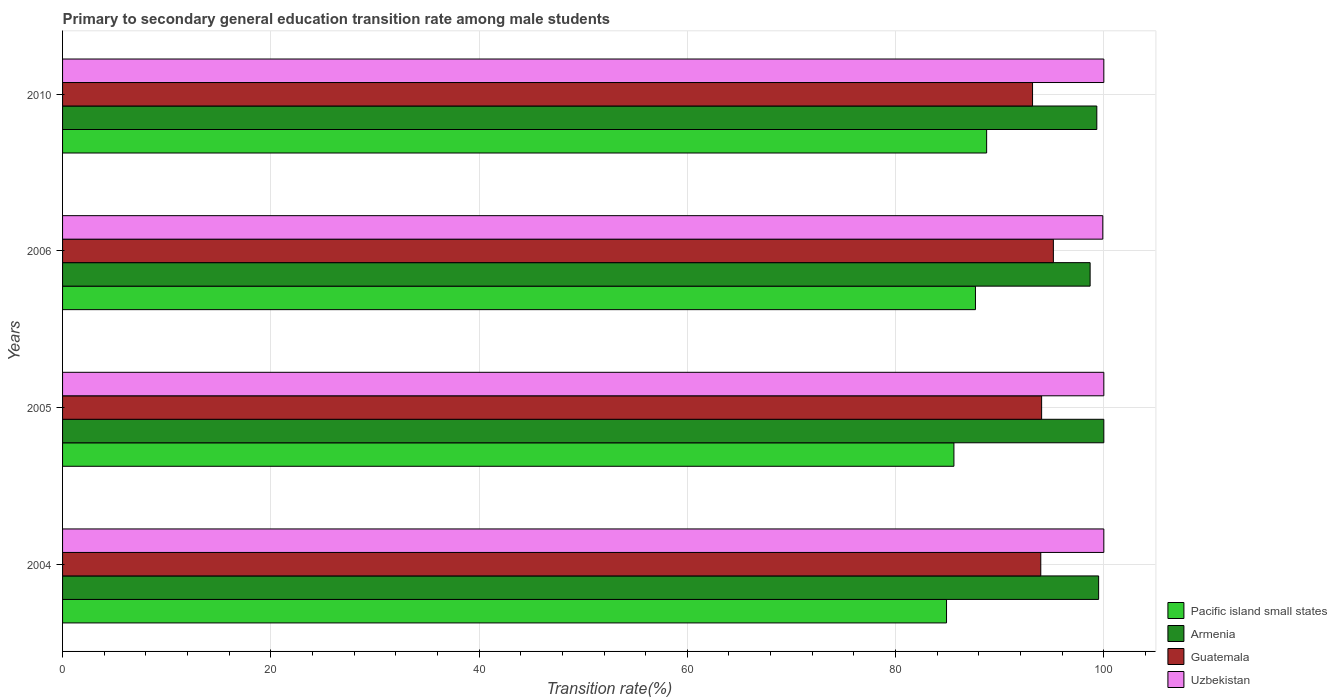How many different coloured bars are there?
Your answer should be very brief. 4. How many groups of bars are there?
Provide a succinct answer. 4. Are the number of bars on each tick of the Y-axis equal?
Provide a short and direct response. Yes. How many bars are there on the 4th tick from the top?
Ensure brevity in your answer.  4. How many bars are there on the 1st tick from the bottom?
Give a very brief answer. 4. What is the label of the 1st group of bars from the top?
Offer a very short reply. 2010. In how many cases, is the number of bars for a given year not equal to the number of legend labels?
Provide a short and direct response. 0. Across all years, what is the maximum transition rate in Uzbekistan?
Give a very brief answer. 100. Across all years, what is the minimum transition rate in Pacific island small states?
Keep it short and to the point. 84.89. In which year was the transition rate in Uzbekistan maximum?
Keep it short and to the point. 2004. What is the total transition rate in Uzbekistan in the graph?
Provide a short and direct response. 399.9. What is the difference between the transition rate in Armenia in 2006 and that in 2010?
Keep it short and to the point. -0.64. What is the difference between the transition rate in Armenia in 2010 and the transition rate in Pacific island small states in 2005?
Your response must be concise. 13.72. What is the average transition rate in Guatemala per year?
Make the answer very short. 94.07. In the year 2010, what is the difference between the transition rate in Armenia and transition rate in Pacific island small states?
Make the answer very short. 10.58. In how many years, is the transition rate in Guatemala greater than 12 %?
Your answer should be very brief. 4. What is the ratio of the transition rate in Armenia in 2005 to that in 2010?
Keep it short and to the point. 1.01. What is the difference between the highest and the lowest transition rate in Armenia?
Your response must be concise. 1.32. Is it the case that in every year, the sum of the transition rate in Pacific island small states and transition rate in Uzbekistan is greater than the sum of transition rate in Armenia and transition rate in Guatemala?
Your answer should be compact. Yes. What does the 2nd bar from the top in 2004 represents?
Make the answer very short. Guatemala. What does the 1st bar from the bottom in 2006 represents?
Your answer should be compact. Pacific island small states. Are all the bars in the graph horizontal?
Your answer should be very brief. Yes. How many years are there in the graph?
Make the answer very short. 4. Are the values on the major ticks of X-axis written in scientific E-notation?
Offer a terse response. No. Does the graph contain grids?
Make the answer very short. Yes. Where does the legend appear in the graph?
Provide a short and direct response. Bottom right. How many legend labels are there?
Make the answer very short. 4. What is the title of the graph?
Offer a very short reply. Primary to secondary general education transition rate among male students. What is the label or title of the X-axis?
Your answer should be very brief. Transition rate(%). What is the Transition rate(%) of Pacific island small states in 2004?
Your response must be concise. 84.89. What is the Transition rate(%) of Armenia in 2004?
Offer a very short reply. 99.5. What is the Transition rate(%) of Guatemala in 2004?
Give a very brief answer. 93.94. What is the Transition rate(%) in Uzbekistan in 2004?
Provide a short and direct response. 100. What is the Transition rate(%) of Pacific island small states in 2005?
Your answer should be compact. 85.6. What is the Transition rate(%) in Guatemala in 2005?
Ensure brevity in your answer.  94.03. What is the Transition rate(%) of Pacific island small states in 2006?
Provide a succinct answer. 87.67. What is the Transition rate(%) in Armenia in 2006?
Keep it short and to the point. 98.68. What is the Transition rate(%) in Guatemala in 2006?
Your answer should be very brief. 95.15. What is the Transition rate(%) of Uzbekistan in 2006?
Provide a short and direct response. 99.9. What is the Transition rate(%) of Pacific island small states in 2010?
Keep it short and to the point. 88.75. What is the Transition rate(%) in Armenia in 2010?
Give a very brief answer. 99.33. What is the Transition rate(%) of Guatemala in 2010?
Your answer should be compact. 93.15. Across all years, what is the maximum Transition rate(%) of Pacific island small states?
Provide a succinct answer. 88.75. Across all years, what is the maximum Transition rate(%) in Armenia?
Provide a succinct answer. 100. Across all years, what is the maximum Transition rate(%) in Guatemala?
Provide a short and direct response. 95.15. Across all years, what is the minimum Transition rate(%) of Pacific island small states?
Provide a succinct answer. 84.89. Across all years, what is the minimum Transition rate(%) of Armenia?
Offer a terse response. 98.68. Across all years, what is the minimum Transition rate(%) of Guatemala?
Offer a very short reply. 93.15. Across all years, what is the minimum Transition rate(%) in Uzbekistan?
Your response must be concise. 99.9. What is the total Transition rate(%) in Pacific island small states in the graph?
Your answer should be very brief. 346.91. What is the total Transition rate(%) in Armenia in the graph?
Offer a very short reply. 397.51. What is the total Transition rate(%) of Guatemala in the graph?
Your answer should be very brief. 376.28. What is the total Transition rate(%) in Uzbekistan in the graph?
Make the answer very short. 399.9. What is the difference between the Transition rate(%) in Pacific island small states in 2004 and that in 2005?
Ensure brevity in your answer.  -0.71. What is the difference between the Transition rate(%) in Armenia in 2004 and that in 2005?
Your answer should be compact. -0.5. What is the difference between the Transition rate(%) of Guatemala in 2004 and that in 2005?
Provide a short and direct response. -0.08. What is the difference between the Transition rate(%) in Uzbekistan in 2004 and that in 2005?
Your answer should be very brief. 0. What is the difference between the Transition rate(%) of Pacific island small states in 2004 and that in 2006?
Give a very brief answer. -2.78. What is the difference between the Transition rate(%) of Armenia in 2004 and that in 2006?
Your answer should be very brief. 0.82. What is the difference between the Transition rate(%) of Guatemala in 2004 and that in 2006?
Keep it short and to the point. -1.21. What is the difference between the Transition rate(%) in Uzbekistan in 2004 and that in 2006?
Make the answer very short. 0.1. What is the difference between the Transition rate(%) in Pacific island small states in 2004 and that in 2010?
Give a very brief answer. -3.85. What is the difference between the Transition rate(%) in Armenia in 2004 and that in 2010?
Offer a terse response. 0.17. What is the difference between the Transition rate(%) in Guatemala in 2004 and that in 2010?
Your response must be concise. 0.79. What is the difference between the Transition rate(%) in Uzbekistan in 2004 and that in 2010?
Your response must be concise. 0. What is the difference between the Transition rate(%) of Pacific island small states in 2005 and that in 2006?
Your answer should be compact. -2.07. What is the difference between the Transition rate(%) in Armenia in 2005 and that in 2006?
Keep it short and to the point. 1.32. What is the difference between the Transition rate(%) of Guatemala in 2005 and that in 2006?
Make the answer very short. -1.13. What is the difference between the Transition rate(%) in Uzbekistan in 2005 and that in 2006?
Your answer should be very brief. 0.1. What is the difference between the Transition rate(%) in Pacific island small states in 2005 and that in 2010?
Offer a terse response. -3.14. What is the difference between the Transition rate(%) of Armenia in 2005 and that in 2010?
Provide a short and direct response. 0.67. What is the difference between the Transition rate(%) of Guatemala in 2005 and that in 2010?
Your answer should be compact. 0.87. What is the difference between the Transition rate(%) of Pacific island small states in 2006 and that in 2010?
Your answer should be compact. -1.07. What is the difference between the Transition rate(%) of Armenia in 2006 and that in 2010?
Your response must be concise. -0.64. What is the difference between the Transition rate(%) of Guatemala in 2006 and that in 2010?
Provide a short and direct response. 2. What is the difference between the Transition rate(%) in Uzbekistan in 2006 and that in 2010?
Your response must be concise. -0.1. What is the difference between the Transition rate(%) of Pacific island small states in 2004 and the Transition rate(%) of Armenia in 2005?
Make the answer very short. -15.11. What is the difference between the Transition rate(%) of Pacific island small states in 2004 and the Transition rate(%) of Guatemala in 2005?
Provide a succinct answer. -9.13. What is the difference between the Transition rate(%) in Pacific island small states in 2004 and the Transition rate(%) in Uzbekistan in 2005?
Make the answer very short. -15.11. What is the difference between the Transition rate(%) of Armenia in 2004 and the Transition rate(%) of Guatemala in 2005?
Offer a very short reply. 5.47. What is the difference between the Transition rate(%) of Armenia in 2004 and the Transition rate(%) of Uzbekistan in 2005?
Offer a very short reply. -0.5. What is the difference between the Transition rate(%) of Guatemala in 2004 and the Transition rate(%) of Uzbekistan in 2005?
Keep it short and to the point. -6.06. What is the difference between the Transition rate(%) in Pacific island small states in 2004 and the Transition rate(%) in Armenia in 2006?
Your answer should be very brief. -13.79. What is the difference between the Transition rate(%) in Pacific island small states in 2004 and the Transition rate(%) in Guatemala in 2006?
Offer a very short reply. -10.26. What is the difference between the Transition rate(%) of Pacific island small states in 2004 and the Transition rate(%) of Uzbekistan in 2006?
Your answer should be compact. -15.01. What is the difference between the Transition rate(%) of Armenia in 2004 and the Transition rate(%) of Guatemala in 2006?
Offer a terse response. 4.35. What is the difference between the Transition rate(%) in Armenia in 2004 and the Transition rate(%) in Uzbekistan in 2006?
Provide a succinct answer. -0.4. What is the difference between the Transition rate(%) in Guatemala in 2004 and the Transition rate(%) in Uzbekistan in 2006?
Your answer should be very brief. -5.96. What is the difference between the Transition rate(%) of Pacific island small states in 2004 and the Transition rate(%) of Armenia in 2010?
Provide a short and direct response. -14.43. What is the difference between the Transition rate(%) of Pacific island small states in 2004 and the Transition rate(%) of Guatemala in 2010?
Keep it short and to the point. -8.26. What is the difference between the Transition rate(%) of Pacific island small states in 2004 and the Transition rate(%) of Uzbekistan in 2010?
Make the answer very short. -15.11. What is the difference between the Transition rate(%) of Armenia in 2004 and the Transition rate(%) of Guatemala in 2010?
Offer a very short reply. 6.35. What is the difference between the Transition rate(%) in Armenia in 2004 and the Transition rate(%) in Uzbekistan in 2010?
Give a very brief answer. -0.5. What is the difference between the Transition rate(%) of Guatemala in 2004 and the Transition rate(%) of Uzbekistan in 2010?
Offer a terse response. -6.06. What is the difference between the Transition rate(%) in Pacific island small states in 2005 and the Transition rate(%) in Armenia in 2006?
Make the answer very short. -13.08. What is the difference between the Transition rate(%) of Pacific island small states in 2005 and the Transition rate(%) of Guatemala in 2006?
Offer a very short reply. -9.55. What is the difference between the Transition rate(%) in Pacific island small states in 2005 and the Transition rate(%) in Uzbekistan in 2006?
Offer a terse response. -14.3. What is the difference between the Transition rate(%) of Armenia in 2005 and the Transition rate(%) of Guatemala in 2006?
Give a very brief answer. 4.85. What is the difference between the Transition rate(%) in Armenia in 2005 and the Transition rate(%) in Uzbekistan in 2006?
Offer a terse response. 0.1. What is the difference between the Transition rate(%) in Guatemala in 2005 and the Transition rate(%) in Uzbekistan in 2006?
Keep it short and to the point. -5.87. What is the difference between the Transition rate(%) of Pacific island small states in 2005 and the Transition rate(%) of Armenia in 2010?
Keep it short and to the point. -13.72. What is the difference between the Transition rate(%) in Pacific island small states in 2005 and the Transition rate(%) in Guatemala in 2010?
Your response must be concise. -7.55. What is the difference between the Transition rate(%) in Pacific island small states in 2005 and the Transition rate(%) in Uzbekistan in 2010?
Your answer should be very brief. -14.4. What is the difference between the Transition rate(%) of Armenia in 2005 and the Transition rate(%) of Guatemala in 2010?
Keep it short and to the point. 6.85. What is the difference between the Transition rate(%) of Armenia in 2005 and the Transition rate(%) of Uzbekistan in 2010?
Offer a very short reply. 0. What is the difference between the Transition rate(%) of Guatemala in 2005 and the Transition rate(%) of Uzbekistan in 2010?
Ensure brevity in your answer.  -5.97. What is the difference between the Transition rate(%) in Pacific island small states in 2006 and the Transition rate(%) in Armenia in 2010?
Ensure brevity in your answer.  -11.66. What is the difference between the Transition rate(%) in Pacific island small states in 2006 and the Transition rate(%) in Guatemala in 2010?
Make the answer very short. -5.48. What is the difference between the Transition rate(%) in Pacific island small states in 2006 and the Transition rate(%) in Uzbekistan in 2010?
Your answer should be very brief. -12.33. What is the difference between the Transition rate(%) in Armenia in 2006 and the Transition rate(%) in Guatemala in 2010?
Give a very brief answer. 5.53. What is the difference between the Transition rate(%) of Armenia in 2006 and the Transition rate(%) of Uzbekistan in 2010?
Offer a terse response. -1.32. What is the difference between the Transition rate(%) in Guatemala in 2006 and the Transition rate(%) in Uzbekistan in 2010?
Your response must be concise. -4.85. What is the average Transition rate(%) of Pacific island small states per year?
Give a very brief answer. 86.73. What is the average Transition rate(%) of Armenia per year?
Give a very brief answer. 99.38. What is the average Transition rate(%) of Guatemala per year?
Provide a succinct answer. 94.07. What is the average Transition rate(%) of Uzbekistan per year?
Your answer should be compact. 99.97. In the year 2004, what is the difference between the Transition rate(%) of Pacific island small states and Transition rate(%) of Armenia?
Provide a succinct answer. -14.61. In the year 2004, what is the difference between the Transition rate(%) of Pacific island small states and Transition rate(%) of Guatemala?
Your answer should be very brief. -9.05. In the year 2004, what is the difference between the Transition rate(%) in Pacific island small states and Transition rate(%) in Uzbekistan?
Give a very brief answer. -15.11. In the year 2004, what is the difference between the Transition rate(%) in Armenia and Transition rate(%) in Guatemala?
Your answer should be very brief. 5.56. In the year 2004, what is the difference between the Transition rate(%) of Armenia and Transition rate(%) of Uzbekistan?
Make the answer very short. -0.5. In the year 2004, what is the difference between the Transition rate(%) of Guatemala and Transition rate(%) of Uzbekistan?
Ensure brevity in your answer.  -6.06. In the year 2005, what is the difference between the Transition rate(%) of Pacific island small states and Transition rate(%) of Armenia?
Make the answer very short. -14.4. In the year 2005, what is the difference between the Transition rate(%) in Pacific island small states and Transition rate(%) in Guatemala?
Make the answer very short. -8.42. In the year 2005, what is the difference between the Transition rate(%) in Pacific island small states and Transition rate(%) in Uzbekistan?
Give a very brief answer. -14.4. In the year 2005, what is the difference between the Transition rate(%) of Armenia and Transition rate(%) of Guatemala?
Your answer should be very brief. 5.97. In the year 2005, what is the difference between the Transition rate(%) in Guatemala and Transition rate(%) in Uzbekistan?
Your answer should be compact. -5.97. In the year 2006, what is the difference between the Transition rate(%) in Pacific island small states and Transition rate(%) in Armenia?
Your answer should be compact. -11.01. In the year 2006, what is the difference between the Transition rate(%) in Pacific island small states and Transition rate(%) in Guatemala?
Your answer should be very brief. -7.48. In the year 2006, what is the difference between the Transition rate(%) in Pacific island small states and Transition rate(%) in Uzbekistan?
Offer a very short reply. -12.23. In the year 2006, what is the difference between the Transition rate(%) of Armenia and Transition rate(%) of Guatemala?
Make the answer very short. 3.53. In the year 2006, what is the difference between the Transition rate(%) in Armenia and Transition rate(%) in Uzbekistan?
Provide a short and direct response. -1.22. In the year 2006, what is the difference between the Transition rate(%) in Guatemala and Transition rate(%) in Uzbekistan?
Give a very brief answer. -4.75. In the year 2010, what is the difference between the Transition rate(%) of Pacific island small states and Transition rate(%) of Armenia?
Keep it short and to the point. -10.58. In the year 2010, what is the difference between the Transition rate(%) in Pacific island small states and Transition rate(%) in Guatemala?
Give a very brief answer. -4.41. In the year 2010, what is the difference between the Transition rate(%) of Pacific island small states and Transition rate(%) of Uzbekistan?
Offer a terse response. -11.25. In the year 2010, what is the difference between the Transition rate(%) of Armenia and Transition rate(%) of Guatemala?
Provide a succinct answer. 6.17. In the year 2010, what is the difference between the Transition rate(%) of Armenia and Transition rate(%) of Uzbekistan?
Your answer should be compact. -0.67. In the year 2010, what is the difference between the Transition rate(%) in Guatemala and Transition rate(%) in Uzbekistan?
Provide a succinct answer. -6.85. What is the ratio of the Transition rate(%) in Pacific island small states in 2004 to that in 2005?
Keep it short and to the point. 0.99. What is the ratio of the Transition rate(%) of Guatemala in 2004 to that in 2005?
Your response must be concise. 1. What is the ratio of the Transition rate(%) of Uzbekistan in 2004 to that in 2005?
Give a very brief answer. 1. What is the ratio of the Transition rate(%) of Pacific island small states in 2004 to that in 2006?
Offer a very short reply. 0.97. What is the ratio of the Transition rate(%) in Armenia in 2004 to that in 2006?
Provide a succinct answer. 1.01. What is the ratio of the Transition rate(%) in Guatemala in 2004 to that in 2006?
Ensure brevity in your answer.  0.99. What is the ratio of the Transition rate(%) of Uzbekistan in 2004 to that in 2006?
Provide a short and direct response. 1. What is the ratio of the Transition rate(%) of Pacific island small states in 2004 to that in 2010?
Make the answer very short. 0.96. What is the ratio of the Transition rate(%) in Guatemala in 2004 to that in 2010?
Your answer should be compact. 1.01. What is the ratio of the Transition rate(%) of Uzbekistan in 2004 to that in 2010?
Your answer should be compact. 1. What is the ratio of the Transition rate(%) of Pacific island small states in 2005 to that in 2006?
Your answer should be very brief. 0.98. What is the ratio of the Transition rate(%) in Armenia in 2005 to that in 2006?
Make the answer very short. 1.01. What is the ratio of the Transition rate(%) of Uzbekistan in 2005 to that in 2006?
Provide a succinct answer. 1. What is the ratio of the Transition rate(%) of Pacific island small states in 2005 to that in 2010?
Your response must be concise. 0.96. What is the ratio of the Transition rate(%) of Armenia in 2005 to that in 2010?
Offer a terse response. 1.01. What is the ratio of the Transition rate(%) of Guatemala in 2005 to that in 2010?
Ensure brevity in your answer.  1.01. What is the ratio of the Transition rate(%) of Uzbekistan in 2005 to that in 2010?
Offer a very short reply. 1. What is the ratio of the Transition rate(%) of Pacific island small states in 2006 to that in 2010?
Provide a succinct answer. 0.99. What is the ratio of the Transition rate(%) in Guatemala in 2006 to that in 2010?
Give a very brief answer. 1.02. What is the difference between the highest and the second highest Transition rate(%) in Pacific island small states?
Keep it short and to the point. 1.07. What is the difference between the highest and the second highest Transition rate(%) in Armenia?
Keep it short and to the point. 0.5. What is the difference between the highest and the second highest Transition rate(%) in Guatemala?
Make the answer very short. 1.13. What is the difference between the highest and the lowest Transition rate(%) in Pacific island small states?
Keep it short and to the point. 3.85. What is the difference between the highest and the lowest Transition rate(%) of Armenia?
Offer a very short reply. 1.32. What is the difference between the highest and the lowest Transition rate(%) of Guatemala?
Ensure brevity in your answer.  2. What is the difference between the highest and the lowest Transition rate(%) of Uzbekistan?
Offer a very short reply. 0.1. 